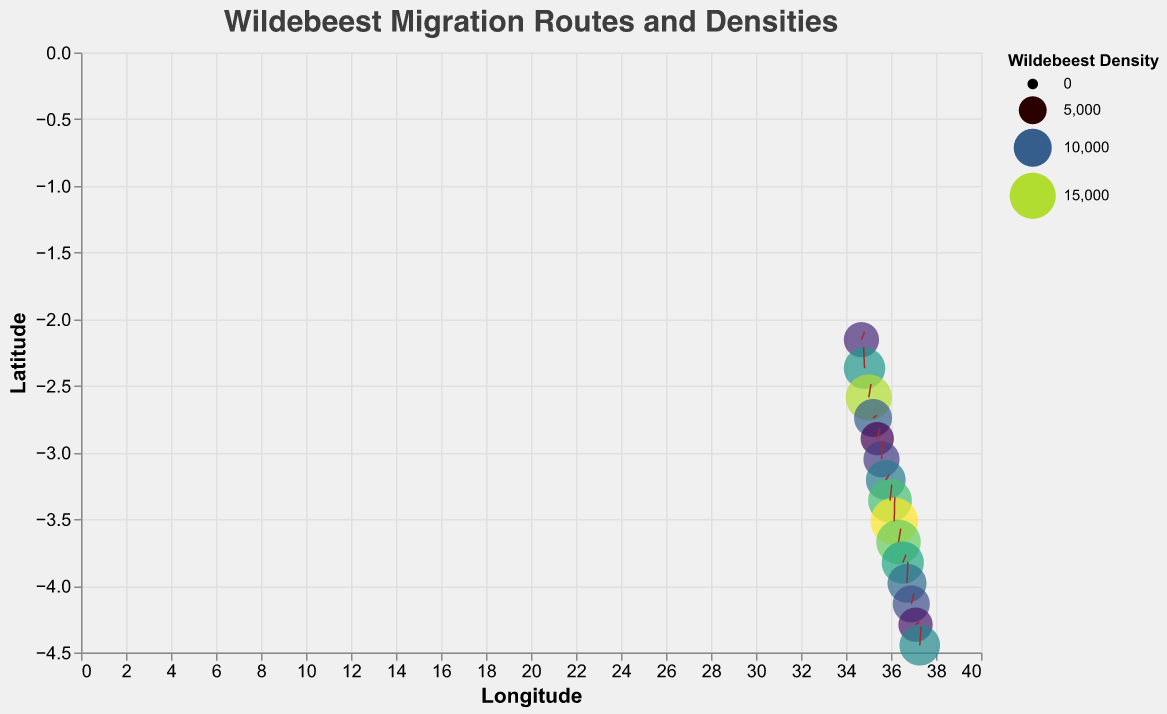What is the title of the figure? The title of the figure is positioned at the top center. It reads "Wildebeest Migration Routes and Densities," and it is styled with a font size of 20, Helvetica font, and color #3d3d3d.
Answer: Wildebeest Migration Routes and Densities What is the range of wildebeest density represented in the figure? The density values are represented as the size of points on the map. The key to these density values is shown on the legend as ranging from 7500 to 16000.
Answer: 7500 to 16000 Which location demonstrates the highest wildebeest density? To identify the highest density, look for the largest size circle on the plot. The largest circle is at Latitude -3.516 and Longitude 36.145 with a density of 16000.
Answer: Latitude -3.516, Longitude 36.145 Is there a general pattern to the migration direction of the wildebeest in the figure? By observing the quiver plot, most brown lines, which represent migration routes, show a similar north-northeasterly direction. The arrows generally move upwards and to the right.
Answer: North-northeast How many data points are plotted in the figure? Each data point corresponds to a specific set of coordinates with associated density and direction information. By counting the number of points where circles are drawn, there are 15 data points in total.
Answer: 15 What is the migration direction at the data point with the coordinates (-2.587, 35.012) and how does the density compare to the maximum density? At this coordinate, the vector direction is (0.5, 0.5). The density at this point is 15000, which is less than the maximum density of 16000.
Answer: Vector direction (0.5, 0.5) and less than 16000 Which data point shows a southward migration direction? Look for the vectors pointing downward. The data point at Latitude -2.368 and Longitude 34.823 has a migration direction of (-0.2, 0.8) indicating a southward component (negative x-direction).
Answer: Latitude -2.368, Longitude 34.823 What can you infer about the migration direction and density at the southernmost point in the figure? The southernmost point is at Latitude -4.446 and Longitude 37.279. The migration direction is (0.3, 0.7), suggesting a northeast direction. The density at this point is 11500.
Answer: Northeast direction, 11500 density Compare the densities between the points with coordinates (-3.206, 35.767) and (-4.291, 37.090). Which has a higher density? The point at (-3.206, 35.767) has a density of 11000, while the point at (-4.291, 37.090) has a density of 8000. Therefore, (-3.206, 35.767) has a higher density.
Answer: -3.206, 35.767 has higher density Does the density correlate with a specific migration direction on the plot? Examining the directions and densities does not show a strict correlation. Higher densities are scattered among different directions. For example, maximum density (16000) moves north-northeast and other directions also have varying densities.
Answer: No strict correlation 